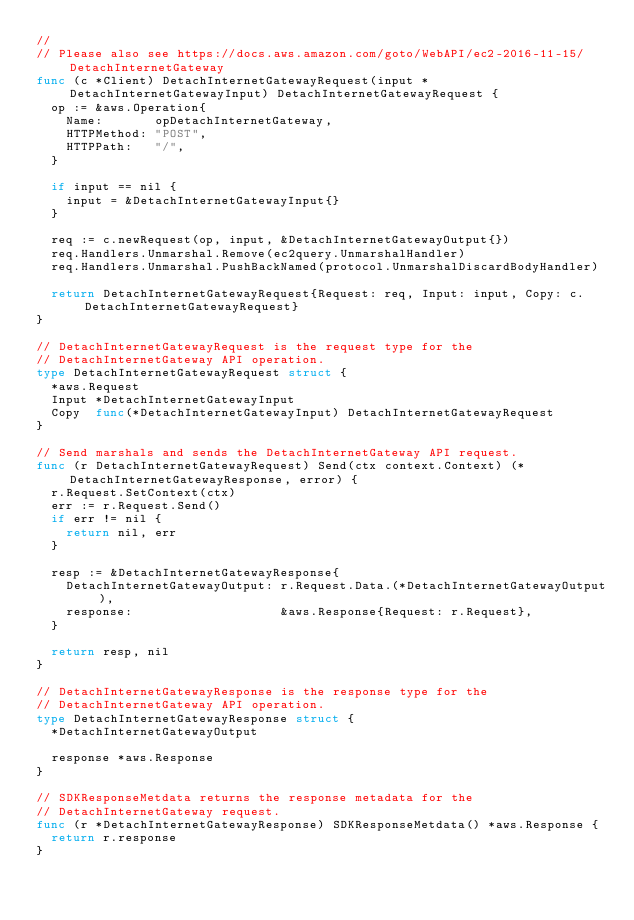<code> <loc_0><loc_0><loc_500><loc_500><_Go_>//
// Please also see https://docs.aws.amazon.com/goto/WebAPI/ec2-2016-11-15/DetachInternetGateway
func (c *Client) DetachInternetGatewayRequest(input *DetachInternetGatewayInput) DetachInternetGatewayRequest {
	op := &aws.Operation{
		Name:       opDetachInternetGateway,
		HTTPMethod: "POST",
		HTTPPath:   "/",
	}

	if input == nil {
		input = &DetachInternetGatewayInput{}
	}

	req := c.newRequest(op, input, &DetachInternetGatewayOutput{})
	req.Handlers.Unmarshal.Remove(ec2query.UnmarshalHandler)
	req.Handlers.Unmarshal.PushBackNamed(protocol.UnmarshalDiscardBodyHandler)

	return DetachInternetGatewayRequest{Request: req, Input: input, Copy: c.DetachInternetGatewayRequest}
}

// DetachInternetGatewayRequest is the request type for the
// DetachInternetGateway API operation.
type DetachInternetGatewayRequest struct {
	*aws.Request
	Input *DetachInternetGatewayInput
	Copy  func(*DetachInternetGatewayInput) DetachInternetGatewayRequest
}

// Send marshals and sends the DetachInternetGateway API request.
func (r DetachInternetGatewayRequest) Send(ctx context.Context) (*DetachInternetGatewayResponse, error) {
	r.Request.SetContext(ctx)
	err := r.Request.Send()
	if err != nil {
		return nil, err
	}

	resp := &DetachInternetGatewayResponse{
		DetachInternetGatewayOutput: r.Request.Data.(*DetachInternetGatewayOutput),
		response:                    &aws.Response{Request: r.Request},
	}

	return resp, nil
}

// DetachInternetGatewayResponse is the response type for the
// DetachInternetGateway API operation.
type DetachInternetGatewayResponse struct {
	*DetachInternetGatewayOutput

	response *aws.Response
}

// SDKResponseMetdata returns the response metadata for the
// DetachInternetGateway request.
func (r *DetachInternetGatewayResponse) SDKResponseMetdata() *aws.Response {
	return r.response
}
</code> 